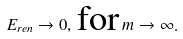<formula> <loc_0><loc_0><loc_500><loc_500>E _ { r e n } \to 0 , \, \text {for} \, m \to \infty .</formula> 